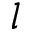<formula> <loc_0><loc_0><loc_500><loc_500>l</formula> 